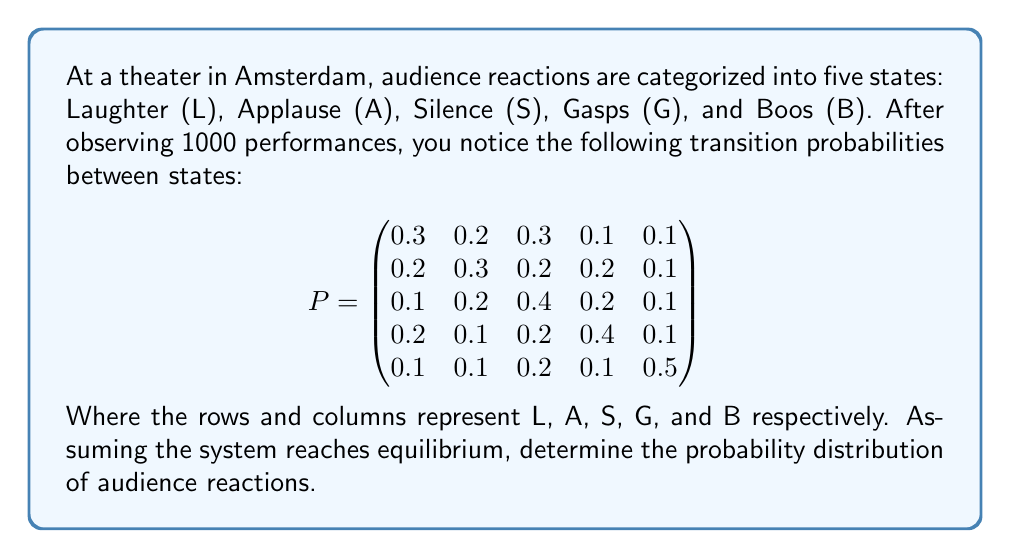Show me your answer to this math problem. To solve this problem, we need to find the stationary distribution of the Markov chain described by the given transition matrix. The stationary distribution $\pi$ satisfies the equation:

$$\pi P = \pi$$

Where $P$ is the transition matrix and $\pi$ is a row vector.

Steps to solve:

1) Let $\pi = (\pi_L, \pi_A, \pi_S, \pi_G, \pi_B)$

2) Write out the system of equations:

   $$\begin{align}
   0.3\pi_L + 0.2\pi_A + 0.1\pi_S + 0.2\pi_G + 0.1\pi_B &= \pi_L \\
   0.2\pi_L + 0.3\pi_A + 0.2\pi_S + 0.1\pi_G + 0.1\pi_B &= \pi_A \\
   0.3\pi_L + 0.2\pi_A + 0.4\pi_S + 0.2\pi_G + 0.2\pi_B &= \pi_S \\
   0.1\pi_L + 0.2\pi_A + 0.2\pi_S + 0.4\pi_G + 0.1\pi_B &= \pi_G \\
   0.1\pi_L + 0.1\pi_A + 0.1\pi_S + 0.1\pi_G + 0.5\pi_B &= \pi_B
   \end{align}$$

3) We also know that the probabilities must sum to 1:

   $$\pi_L + \pi_A + \pi_S + \pi_G + \pi_B = 1$$

4) Solve this system of equations. One way is to subtract $\pi_i$ from both sides of each equation, giving:

   $$\begin{align}
   -0.7\pi_L + 0.2\pi_A + 0.1\pi_S + 0.2\pi_G + 0.1\pi_B &= 0 \\
   0.2\pi_L - 0.7\pi_A + 0.2\pi_S + 0.1\pi_G + 0.1\pi_B &= 0 \\
   0.3\pi_L + 0.2\pi_A - 0.6\pi_S + 0.2\pi_G + 0.2\pi_B &= 0 \\
   0.1\pi_L + 0.2\pi_A + 0.2\pi_S - 0.6\pi_G + 0.1\pi_B &= 0 \\
   0.1\pi_L + 0.1\pi_A + 0.1\pi_S + 0.1\pi_G - 0.5\pi_B &= 0 \\
   \pi_L + \pi_A + \pi_S + \pi_G + \pi_B &= 1
   \end{align}$$

5) Solve this system of equations using a method like Gaussian elimination or a computer algebra system.

6) The solution is approximately:

   $$\pi_L \approx 0.2105, \pi_A \approx 0.2105, \pi_S \approx 0.2632, \pi_G \approx 0.1842, \pi_B \approx 0.1316$$
Answer: $(0.2105, 0.2105, 0.2632, 0.1842, 0.1316)$ 